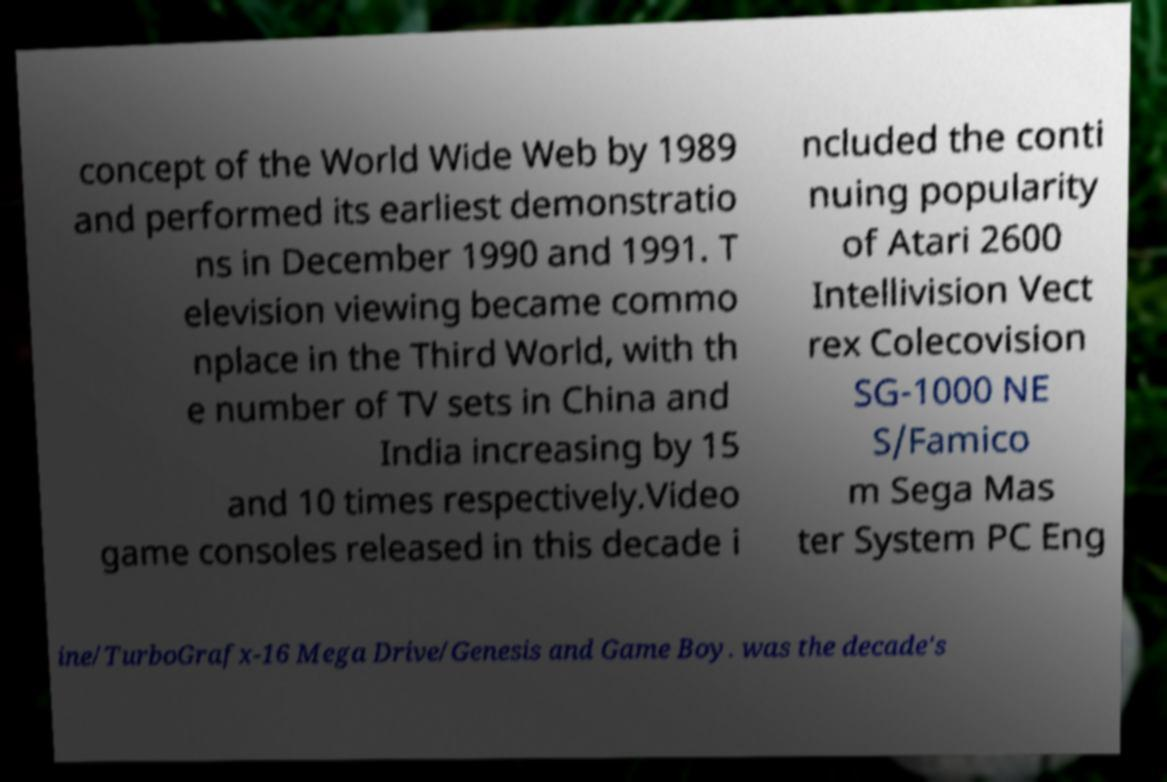What messages or text are displayed in this image? I need them in a readable, typed format. concept of the World Wide Web by 1989 and performed its earliest demonstratio ns in December 1990 and 1991. T elevision viewing became commo nplace in the Third World, with th e number of TV sets in China and India increasing by 15 and 10 times respectively.Video game consoles released in this decade i ncluded the conti nuing popularity of Atari 2600 Intellivision Vect rex Colecovision SG-1000 NE S/Famico m Sega Mas ter System PC Eng ine/TurboGrafx-16 Mega Drive/Genesis and Game Boy. was the decade's 